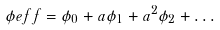<formula> <loc_0><loc_0><loc_500><loc_500>\phi e f f = \phi _ { 0 } + a \phi _ { 1 } + a ^ { 2 } \phi _ { 2 } + \dots</formula> 